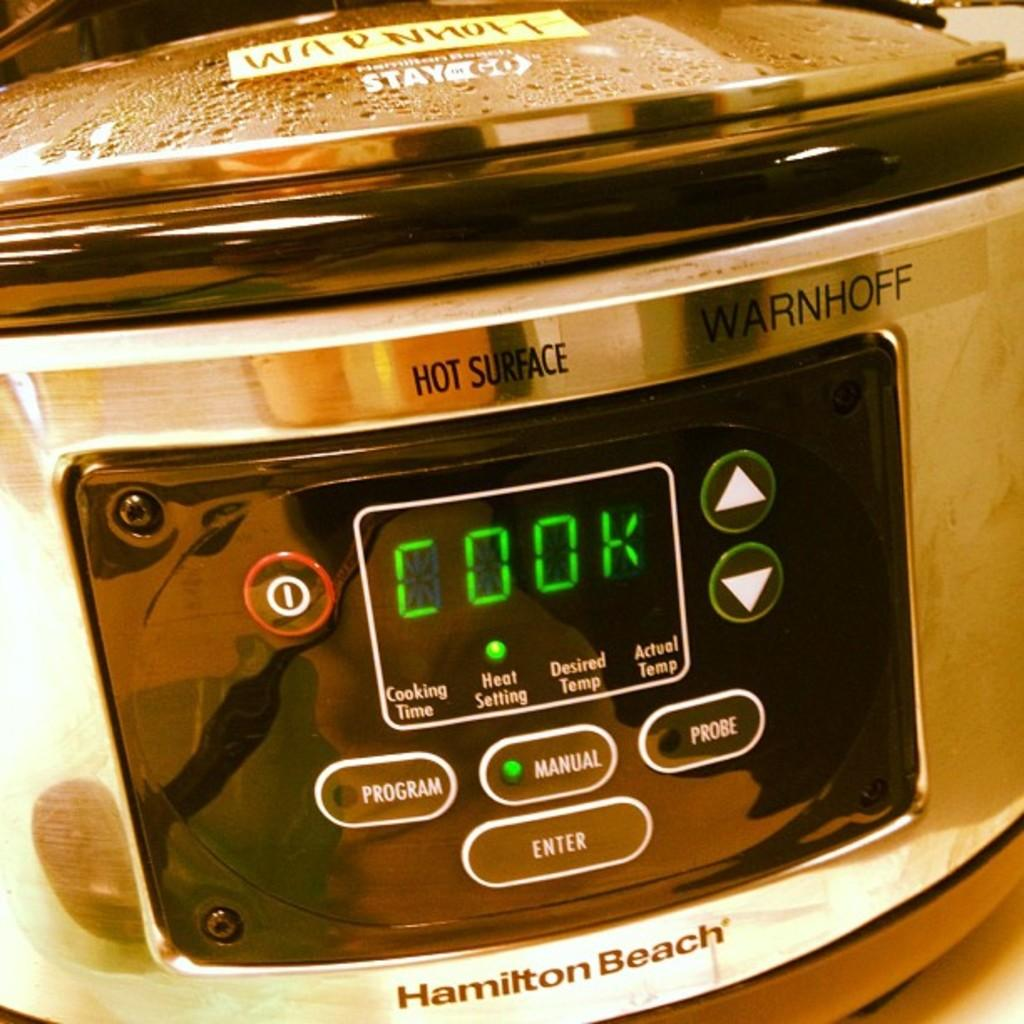What type of cooking appliance is in the image? There is an electric cooker in the image. What features does the electric cooker have? The electric cooker has buttons and a digital display. Is there any part of the electric cooker that can be opened or closed? Yes, there is a lid on the electric cooker. How many jellyfish are swimming in the electric cooker in the image? There are no jellyfish present in the image; it features an electric cooker with buttons, a digital display, and a lid. 